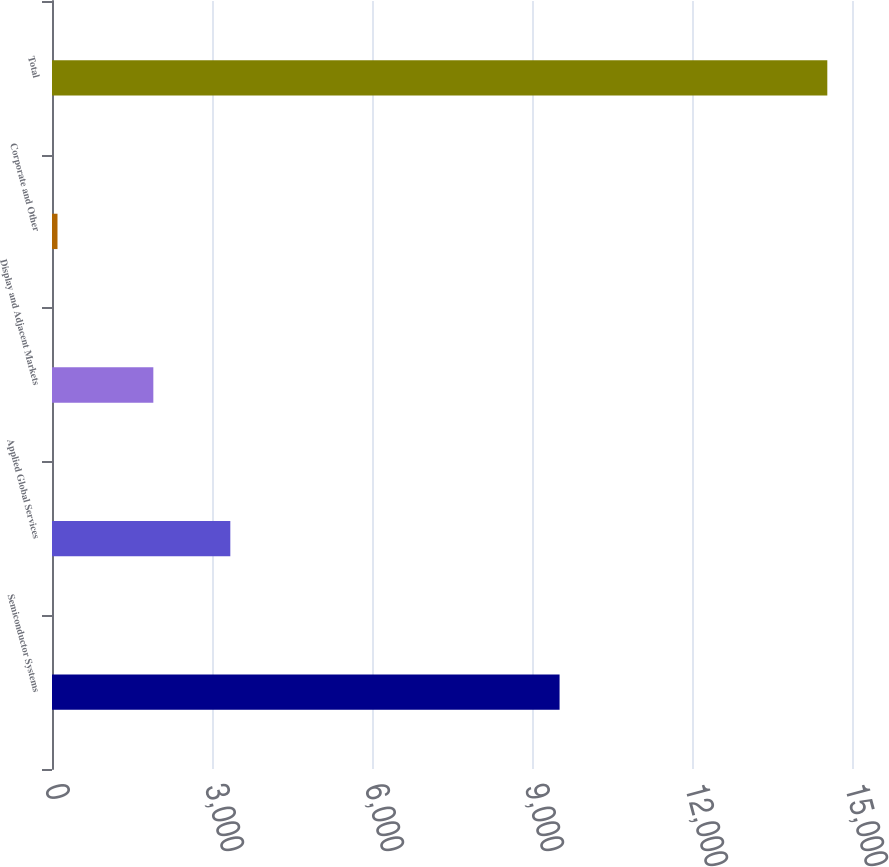Convert chart. <chart><loc_0><loc_0><loc_500><loc_500><bar_chart><fcel>Semiconductor Systems<fcel>Applied Global Services<fcel>Display and Adjacent Markets<fcel>Corporate and Other<fcel>Total<nl><fcel>9517<fcel>3343.4<fcel>1900<fcel>103<fcel>14537<nl></chart> 